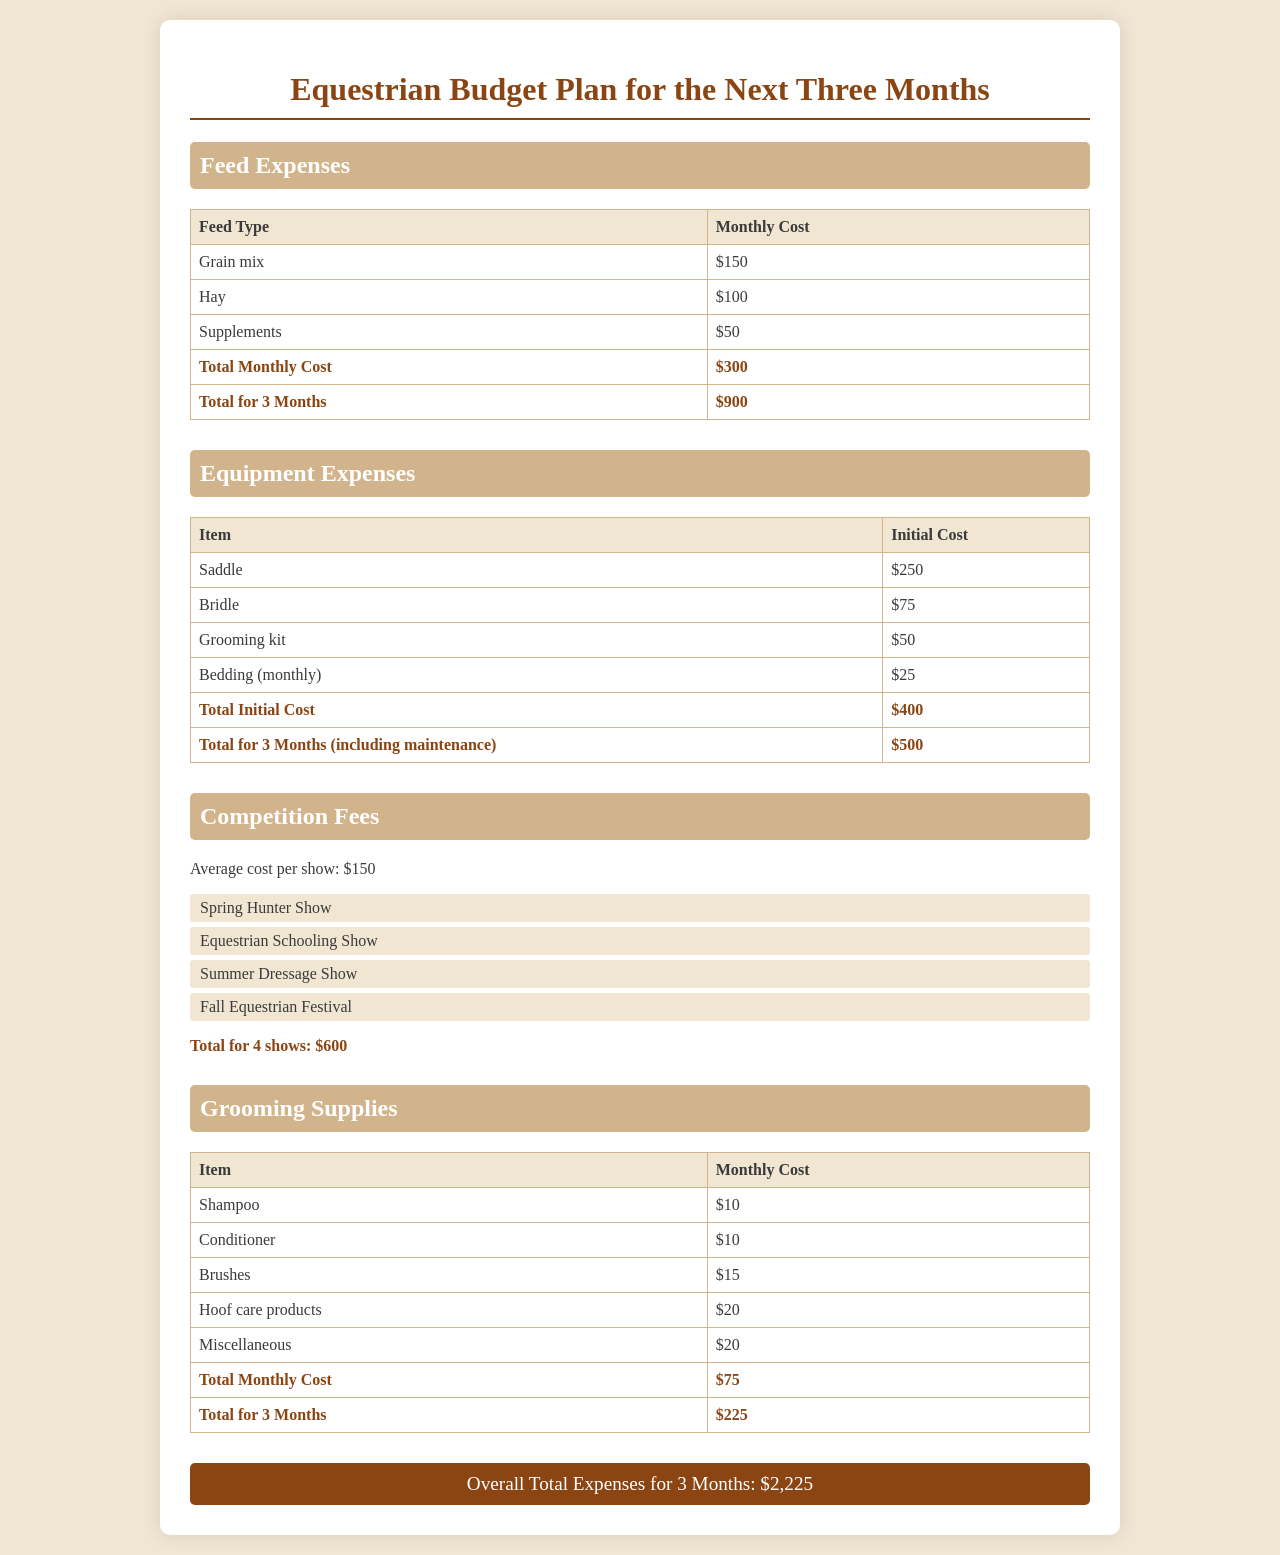What is the monthly cost for hay? The monthly cost for hay is listed in the Feed Expenses section of the document.
Answer: $100 What is the total cost for feed over three months? The total cost for feed is calculated in the Feed Expenses section as $300 per month for three months.
Answer: $900 What is the cost of the saddle? The cost of the saddle is specified in the Equipment Expenses section of the document.
Answer: $250 How many shows are planned for the next three months? The number of shows is mentioned in the Competition Fees section as four shows.
Answer: 4 What are the total grooming supply expenses for three months? The total grooming supply expenses can be found in the Grooming Supplies section as $75 monthly for three months.
Answer: $225 What is the total initial cost for equipment? The total initial cost for equipment is provided in the Equipment Expenses overview.
Answer: $400 What is the average cost per show? The average cost per show is stated in the Competition Fees section of the document.
Answer: $150 What is the overall total expenses for three months? The overall total expenses can be found at the bottom of the document, adding all sections together.
Answer: $2,225 